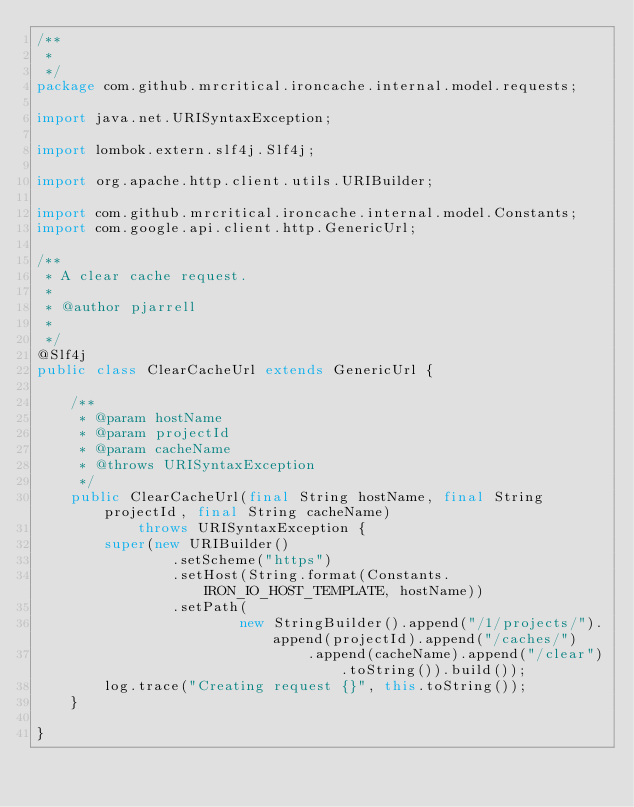<code> <loc_0><loc_0><loc_500><loc_500><_Java_>/**
 *
 */
package com.github.mrcritical.ironcache.internal.model.requests;

import java.net.URISyntaxException;

import lombok.extern.slf4j.Slf4j;

import org.apache.http.client.utils.URIBuilder;

import com.github.mrcritical.ironcache.internal.model.Constants;
import com.google.api.client.http.GenericUrl;

/**
 * A clear cache request.
 *
 * @author pjarrell
 *
 */
@Slf4j
public class ClearCacheUrl extends GenericUrl {

	/**
	 * @param hostName
	 * @param projectId
	 * @param cacheName
	 * @throws URISyntaxException
	 */
	public ClearCacheUrl(final String hostName, final String projectId, final String cacheName)
			throws URISyntaxException {
		super(new URIBuilder()
				.setScheme("https")
				.setHost(String.format(Constants.IRON_IO_HOST_TEMPLATE, hostName))
				.setPath(
						new StringBuilder().append("/1/projects/").append(projectId).append("/caches/")
								.append(cacheName).append("/clear").toString()).build());
		log.trace("Creating request {}", this.toString());
	}

}
</code> 